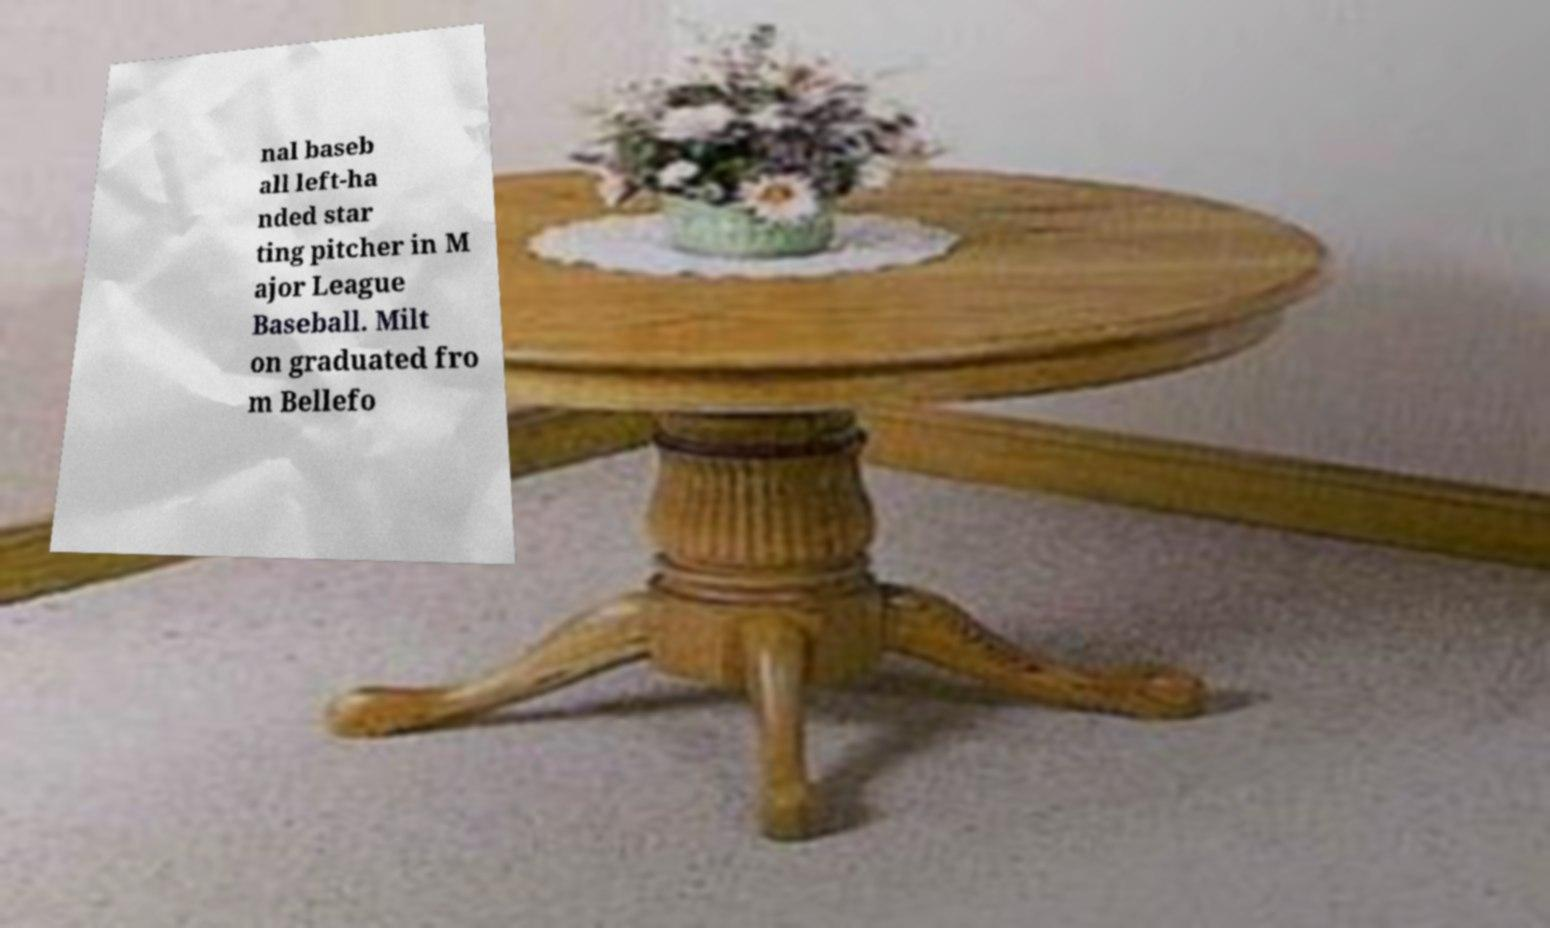What messages or text are displayed in this image? I need them in a readable, typed format. nal baseb all left-ha nded star ting pitcher in M ajor League Baseball. Milt on graduated fro m Bellefo 